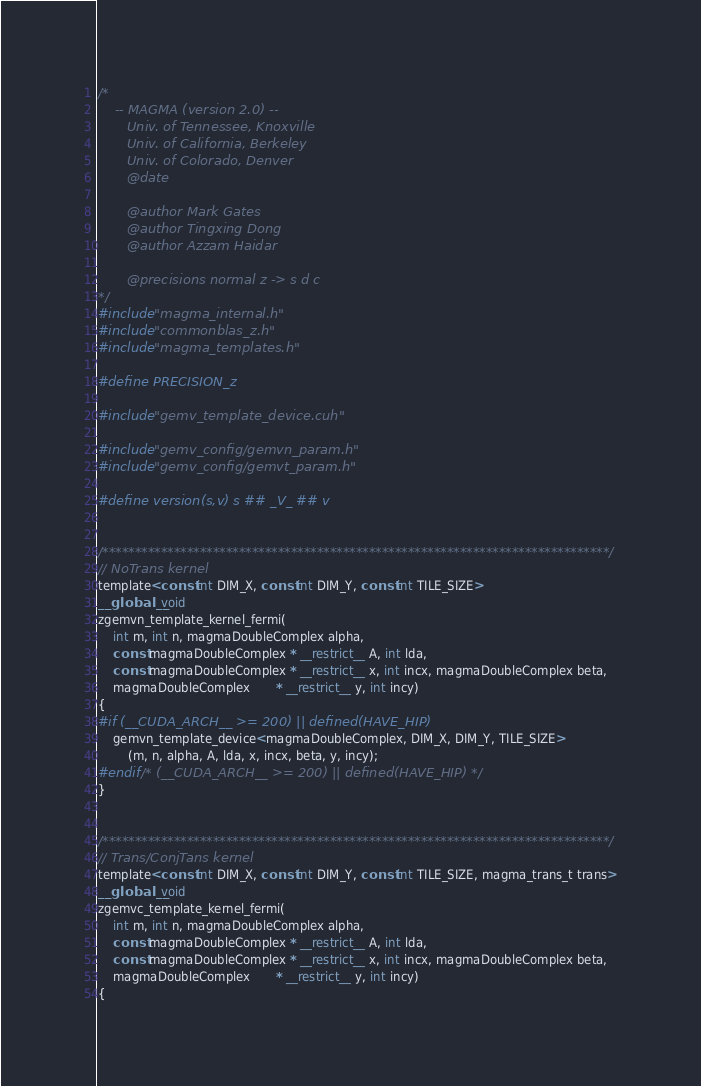<code> <loc_0><loc_0><loc_500><loc_500><_Cuda_>/*
    -- MAGMA (version 2.0) --
       Univ. of Tennessee, Knoxville
       Univ. of California, Berkeley
       Univ. of Colorado, Denver
       @date
       
       @author Mark Gates
       @author Tingxing Dong
       @author Azzam Haidar

       @precisions normal z -> s d c
*/
#include "magma_internal.h"
#include "commonblas_z.h"
#include "magma_templates.h"

#define PRECISION_z

#include "gemv_template_device.cuh"

#include "gemv_config/gemvn_param.h"
#include "gemv_config/gemvt_param.h"

#define version(s,v) s ## _V_ ## v


/******************************************************************************/
// NoTrans kernel
template<const int DIM_X, const int DIM_Y, const int TILE_SIZE>
__global__ void
zgemvn_template_kernel_fermi(
    int m, int n, magmaDoubleComplex alpha,
    const magmaDoubleComplex * __restrict__ A, int lda,
    const magmaDoubleComplex * __restrict__ x, int incx, magmaDoubleComplex beta,
    magmaDoubleComplex       * __restrict__ y, int incy)
{
#if (__CUDA_ARCH__ >= 200) || defined(HAVE_HIP)
    gemvn_template_device<magmaDoubleComplex, DIM_X, DIM_Y, TILE_SIZE>
        (m, n, alpha, A, lda, x, incx, beta, y, incy);
#endif /* (__CUDA_ARCH__ >= 200) || defined(HAVE_HIP) */
}


/******************************************************************************/
// Trans/ConjTans kernel
template<const int DIM_X, const int DIM_Y, const int TILE_SIZE, magma_trans_t trans>
__global__ void
zgemvc_template_kernel_fermi(
    int m, int n, magmaDoubleComplex alpha,
    const magmaDoubleComplex * __restrict__ A, int lda,
    const magmaDoubleComplex * __restrict__ x, int incx, magmaDoubleComplex beta,
    magmaDoubleComplex       * __restrict__ y, int incy)
{</code> 